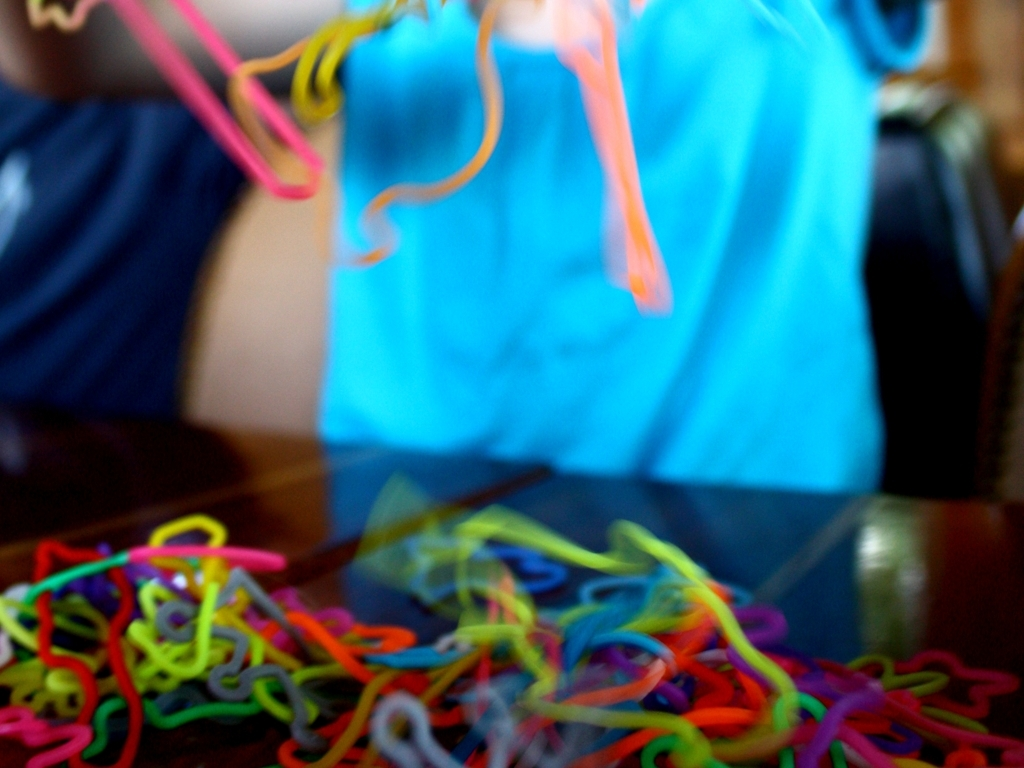What feeling does the use of blur and the arrangement of colors in this image evoke? The blur conveys a sense of action or motion, giving the image a dynamic feel. The bright and assorted colors provide a cheerful and playful vibe, often associated with childhood and creativity. 